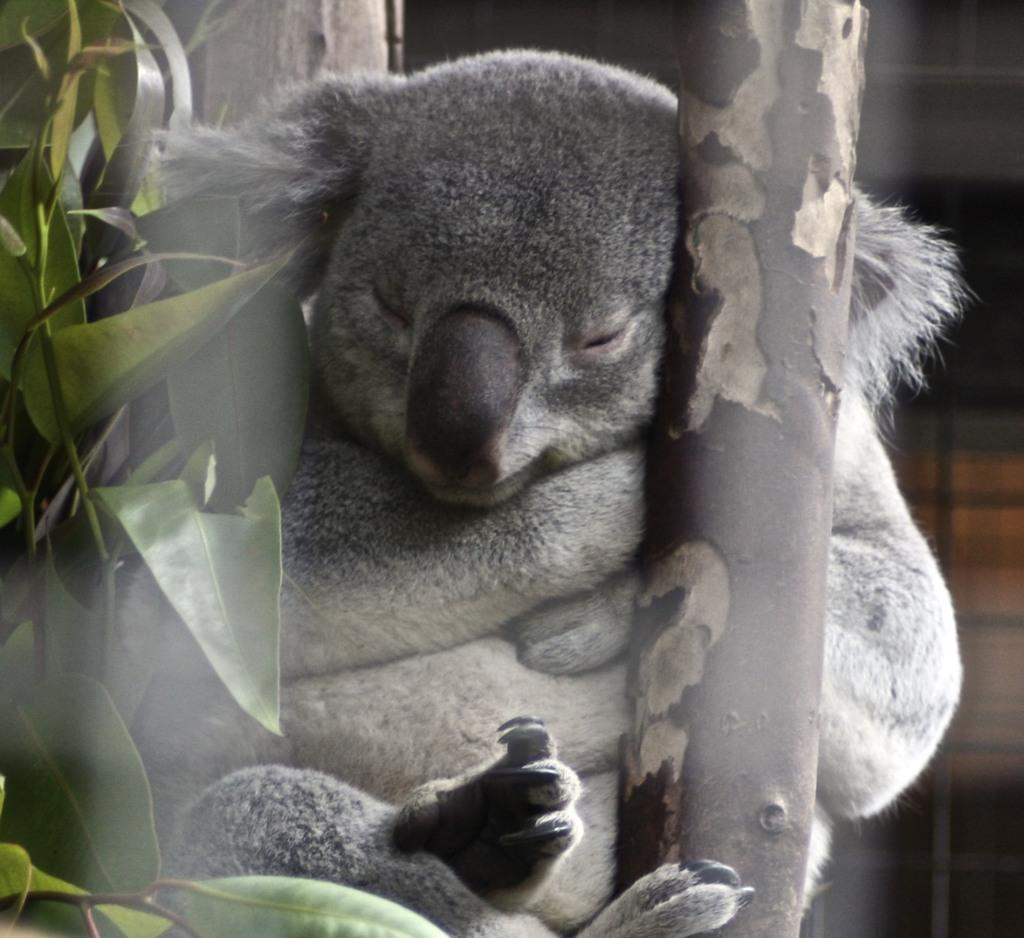What type of animals are in the image? There are koalas in the image. What are the koalas holding or eating in the image? The koalas are holding or eating leaves in the image. What else can be seen in the image besides the koalas? There are branches in the image. How would you describe the background of the image? The background of the image is blurry. What type of screw can be seen in the image? There is no screw present in the image; it features koalas with leaves and branches. What sound do the koalas make in the image? The image is a still picture, so no sounds can be heard or depicted. 